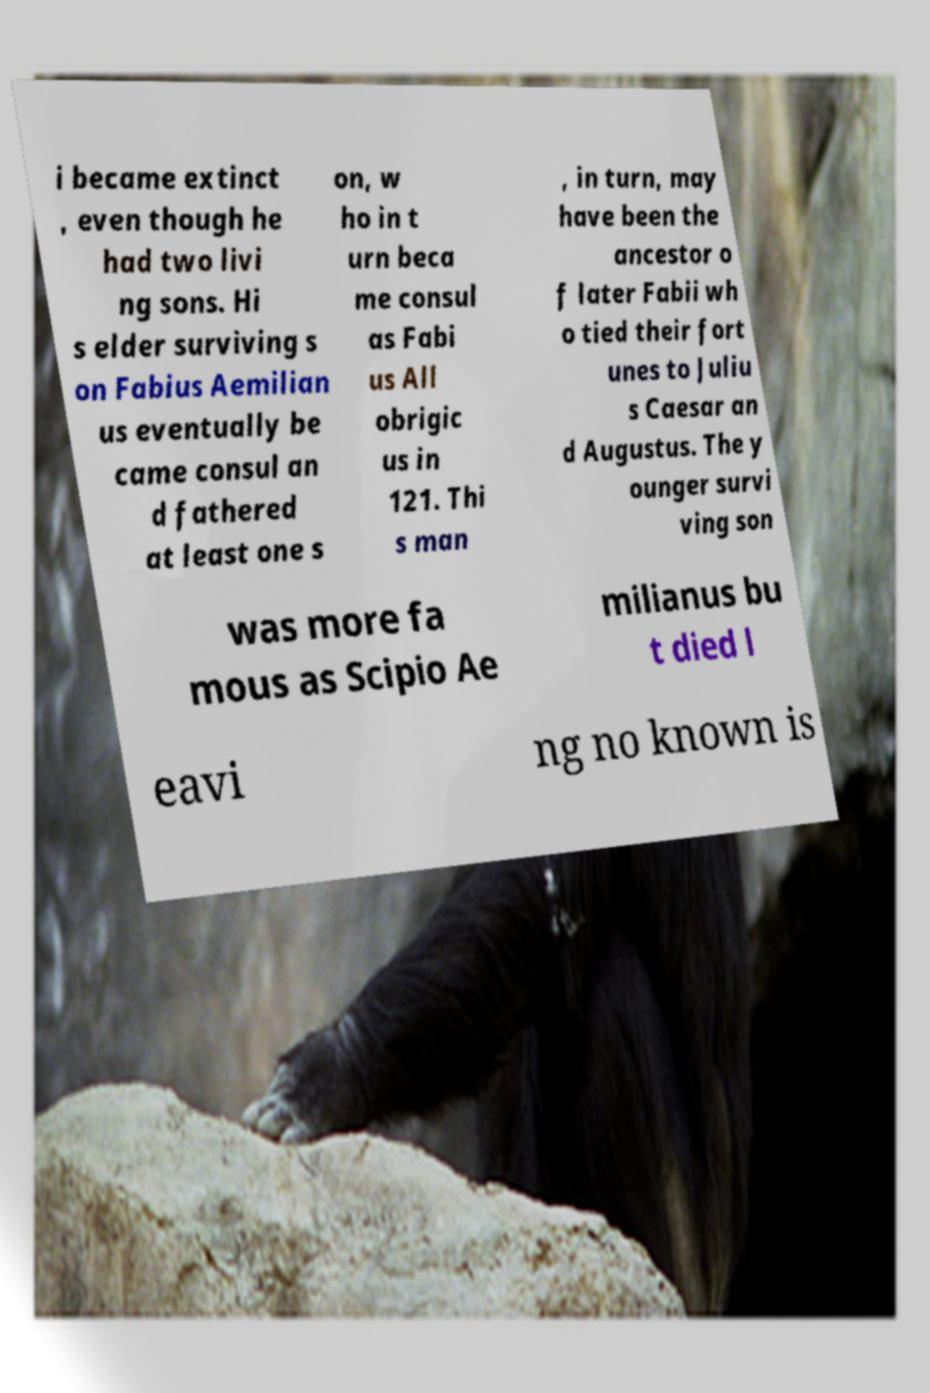For documentation purposes, I need the text within this image transcribed. Could you provide that? i became extinct , even though he had two livi ng sons. Hi s elder surviving s on Fabius Aemilian us eventually be came consul an d fathered at least one s on, w ho in t urn beca me consul as Fabi us All obrigic us in 121. Thi s man , in turn, may have been the ancestor o f later Fabii wh o tied their fort unes to Juliu s Caesar an d Augustus. The y ounger survi ving son was more fa mous as Scipio Ae milianus bu t died l eavi ng no known is 